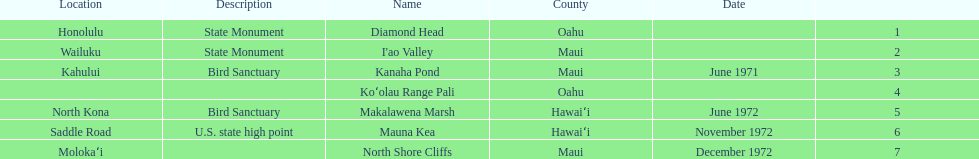How many names do not have a description? 2. 